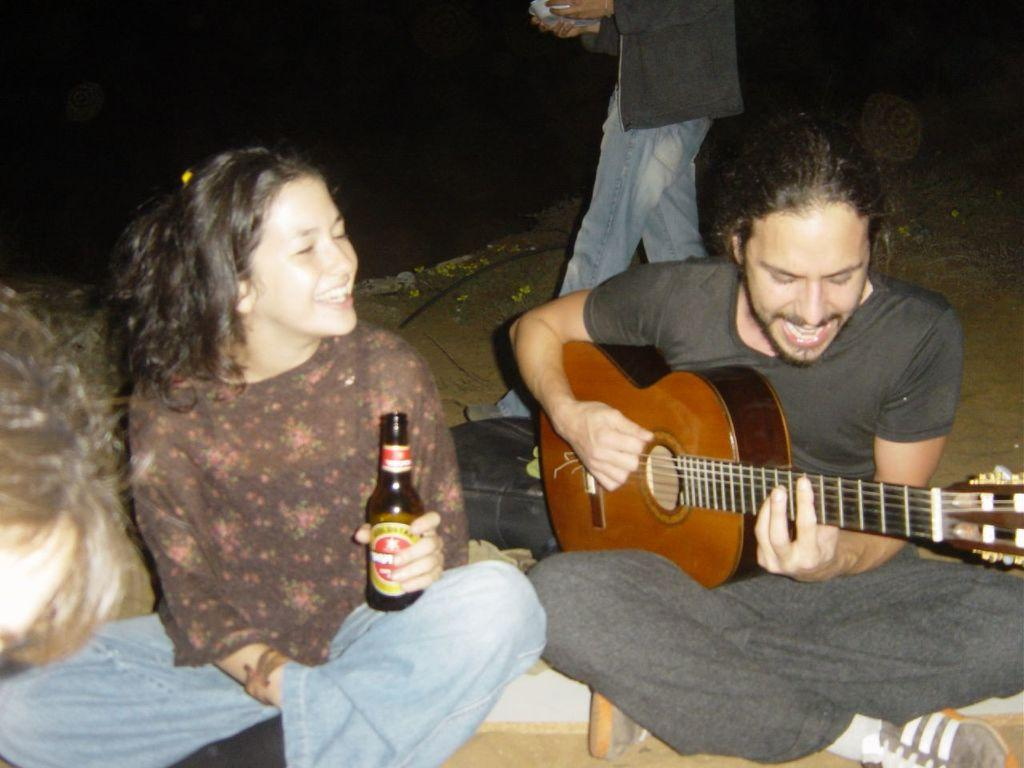Who are the people in the image? There is a woman and a man in the image. What are the woman and the man doing in the image? The woman and the man are sitting on the floor. What is the man doing while sitting on the floor? The man is playing a guitar. What is the woman holding while sitting on the floor? The woman is holding a bottle. What type of base is supporting the guitar in the image? There is no base supporting the guitar in the image; the man is holding the guitar while playing it. 